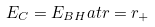<formula> <loc_0><loc_0><loc_500><loc_500>E _ { C } = E _ { B H } a t r = r _ { + }</formula> 